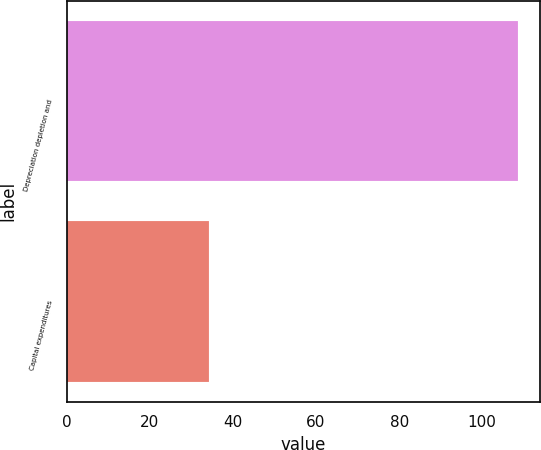<chart> <loc_0><loc_0><loc_500><loc_500><bar_chart><fcel>Depreciation depletion and<fcel>Capital expenditures<nl><fcel>108.6<fcel>34.2<nl></chart> 